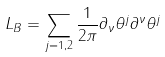<formula> <loc_0><loc_0><loc_500><loc_500>L _ { B } = \sum _ { j = 1 , 2 } \frac { 1 } { 2 \pi } \partial _ { \nu } \theta ^ { j } \partial ^ { \nu } \theta ^ { j }</formula> 